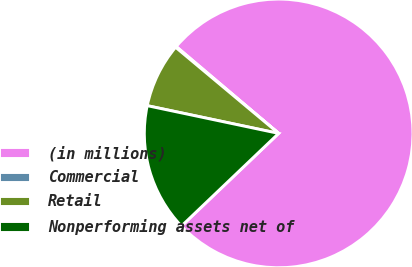<chart> <loc_0><loc_0><loc_500><loc_500><pie_chart><fcel>(in millions)<fcel>Commercial<fcel>Retail<fcel>Nonperforming assets net of<nl><fcel>76.69%<fcel>0.11%<fcel>7.77%<fcel>15.43%<nl></chart> 